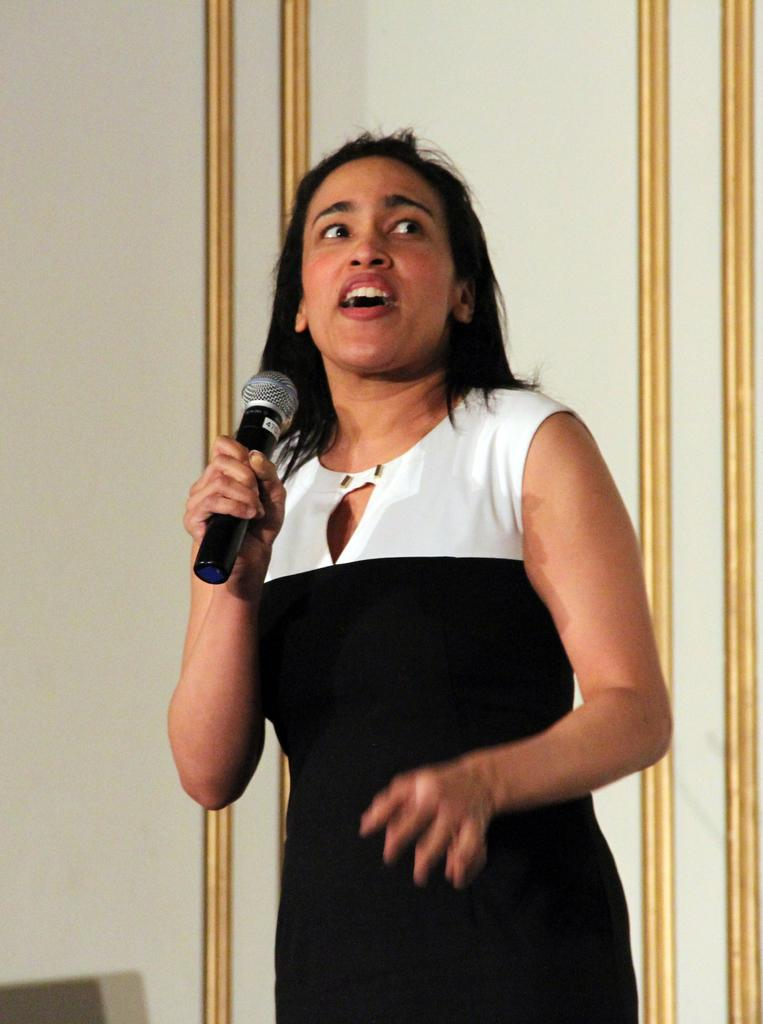Who is the main subject in the image? There is a woman in the image. What is the woman doing with the microphone? The woman is catching a microphone. What is the woman doing while holding the microphone? The woman is talking. What can be seen near the woman in the image? There are bars near the woman. What is the background of the image? There is a wall in the image. What type of kettle is visible on the wall in the image? There is no kettle present in the image; only a woman, a microphone, bars, and a wall are visible. 